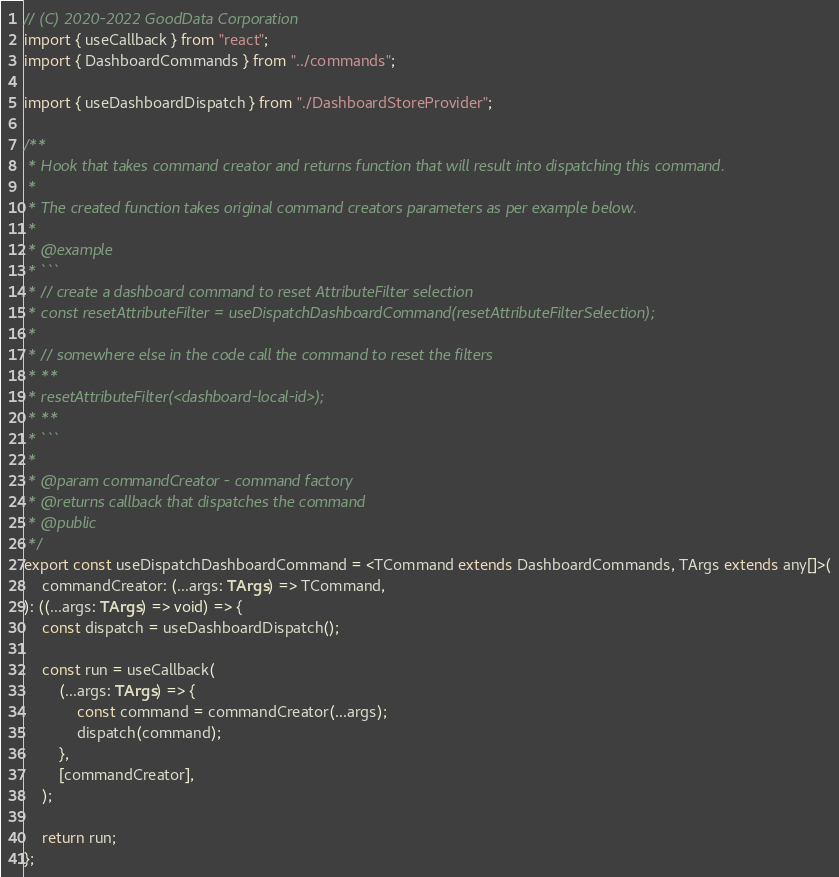Convert code to text. <code><loc_0><loc_0><loc_500><loc_500><_TypeScript_>// (C) 2020-2022 GoodData Corporation
import { useCallback } from "react";
import { DashboardCommands } from "../commands";

import { useDashboardDispatch } from "./DashboardStoreProvider";

/**
 * Hook that takes command creator and returns function that will result into dispatching this command.
 *
 * The created function takes original command creators parameters as per example below.
 *
 * @example
 * ```
 * // create a dashboard command to reset AttributeFilter selection
 * const resetAttributeFilter = useDispatchDashboardCommand(resetAttributeFilterSelection);
 *
 * // somewhere else in the code call the command to reset the filters
 * **
 * resetAttributeFilter(<dashboard-local-id>);
 * **
 * ```
 *
 * @param commandCreator - command factory
 * @returns callback that dispatches the command
 * @public
 */
export const useDispatchDashboardCommand = <TCommand extends DashboardCommands, TArgs extends any[]>(
    commandCreator: (...args: TArgs) => TCommand,
): ((...args: TArgs) => void) => {
    const dispatch = useDashboardDispatch();

    const run = useCallback(
        (...args: TArgs) => {
            const command = commandCreator(...args);
            dispatch(command);
        },
        [commandCreator],
    );

    return run;
};
</code> 